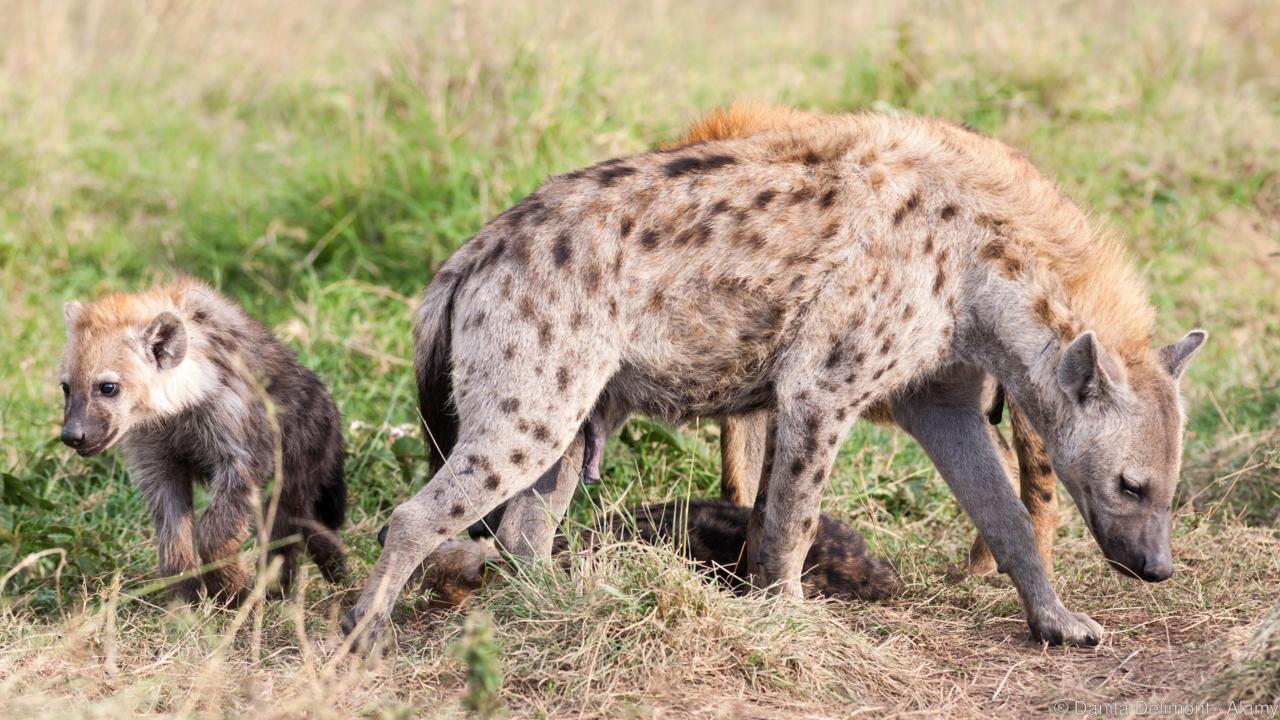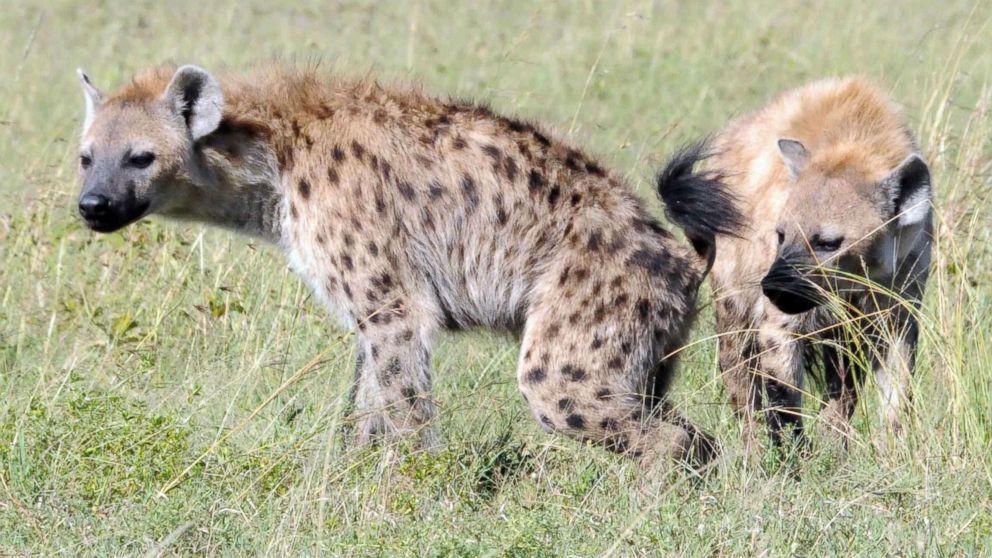The first image is the image on the left, the second image is the image on the right. Assess this claim about the two images: "There are four hyenas in the image pair.". Correct or not? Answer yes or no. Yes. 